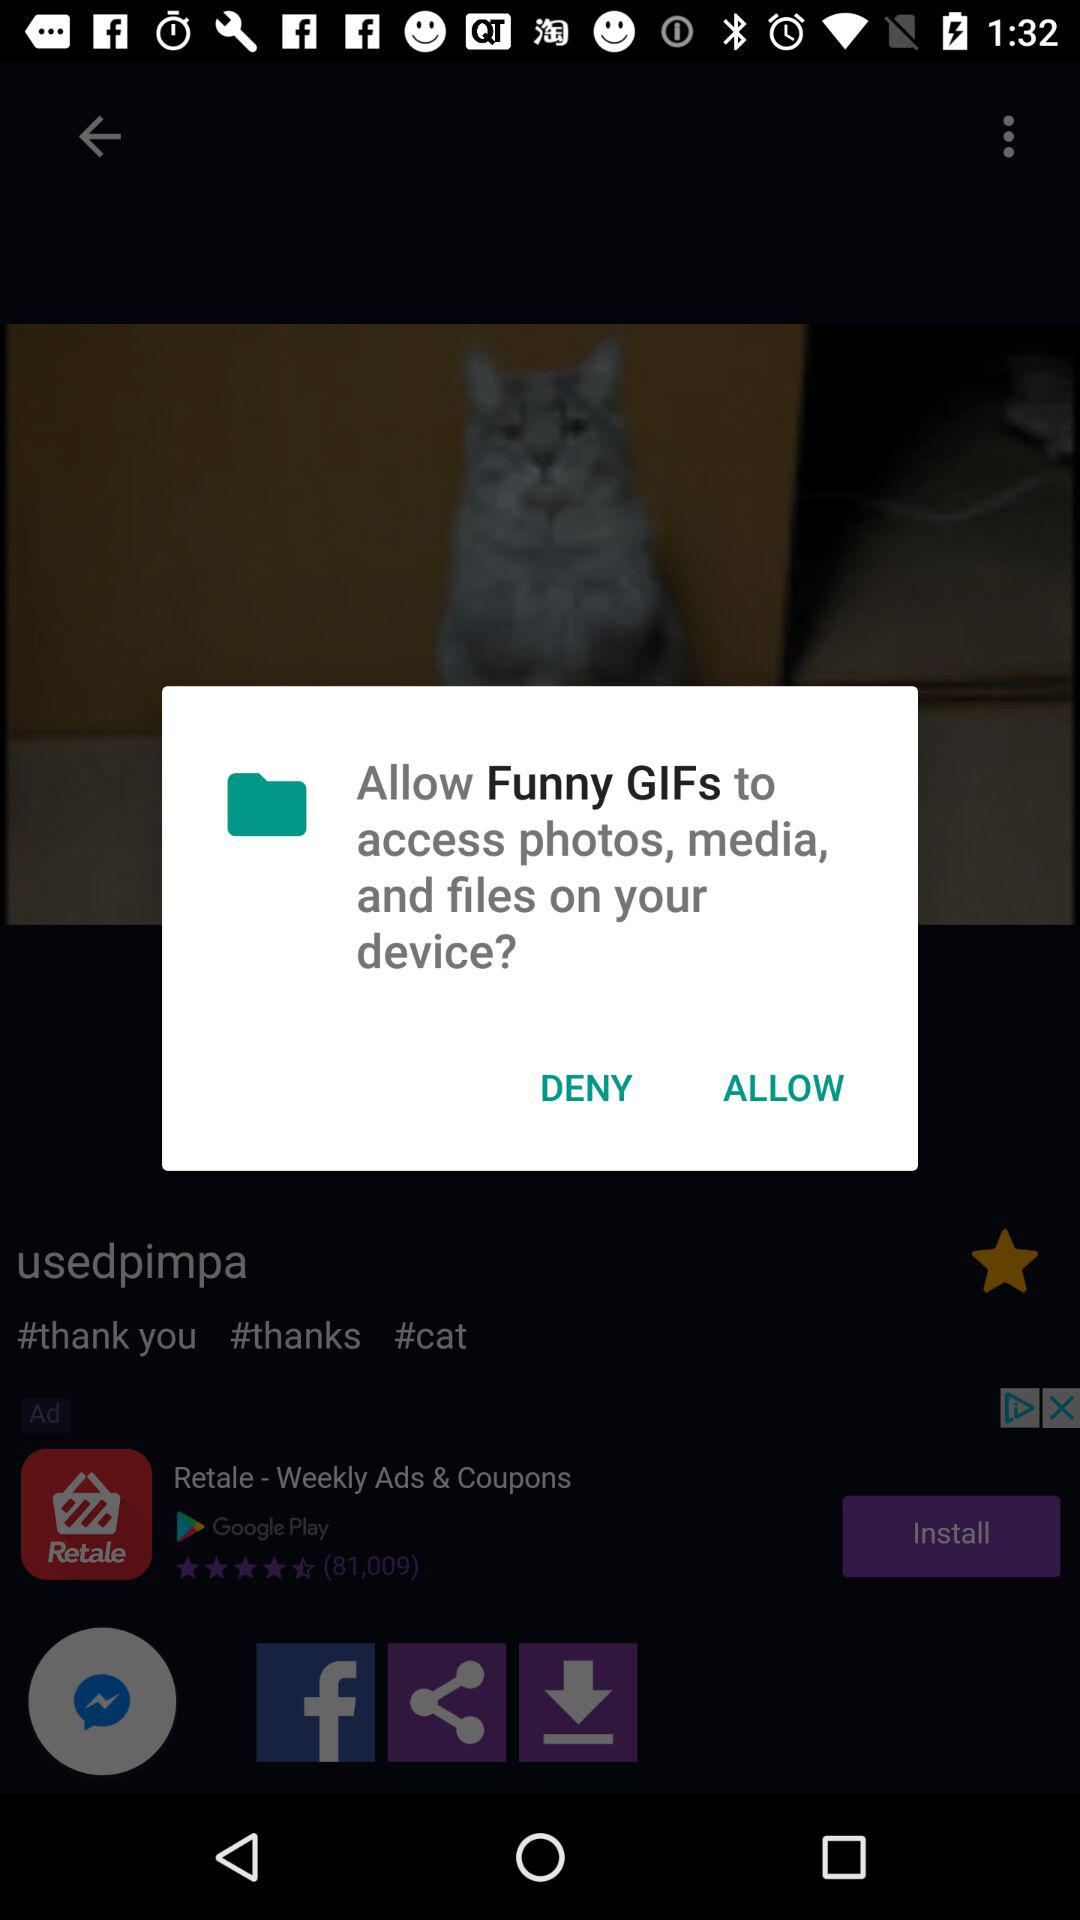What application has asked for permission? The application that has asked for permission is "Funny GIFs". 